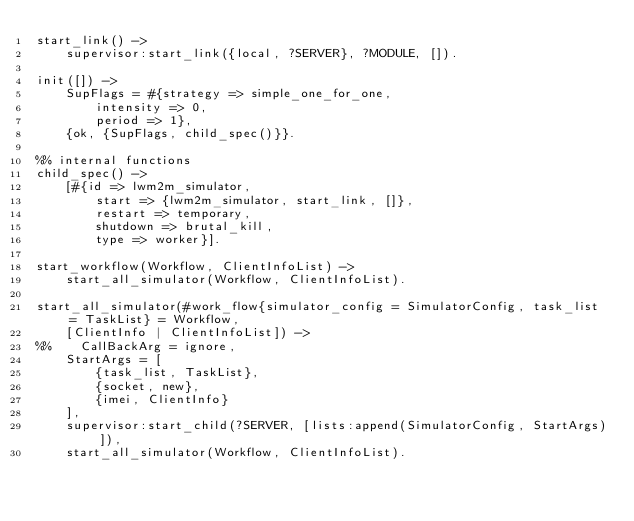<code> <loc_0><loc_0><loc_500><loc_500><_Erlang_>start_link() ->
    supervisor:start_link({local, ?SERVER}, ?MODULE, []).

init([]) ->
    SupFlags = #{strategy => simple_one_for_one,
        intensity => 0,
        period => 1},
    {ok, {SupFlags, child_spec()}}.

%% internal functions
child_spec() ->
    [#{id => lwm2m_simulator,
        start => {lwm2m_simulator, start_link, []},
        restart => temporary,
        shutdown => brutal_kill,
        type => worker}].

start_workflow(Workflow, ClientInfoList) ->
    start_all_simulator(Workflow, ClientInfoList).

start_all_simulator(#work_flow{simulator_config = SimulatorConfig, task_list = TaskList} = Workflow,
    [ClientInfo | ClientInfoList]) ->
%%    CallBackArg = ignore,
    StartArgs = [
        {task_list, TaskList},
        {socket, new},
        {imei, ClientInfo}
    ],
    supervisor:start_child(?SERVER, [lists:append(SimulatorConfig, StartArgs)]),
    start_all_simulator(Workflow, ClientInfoList).


</code> 